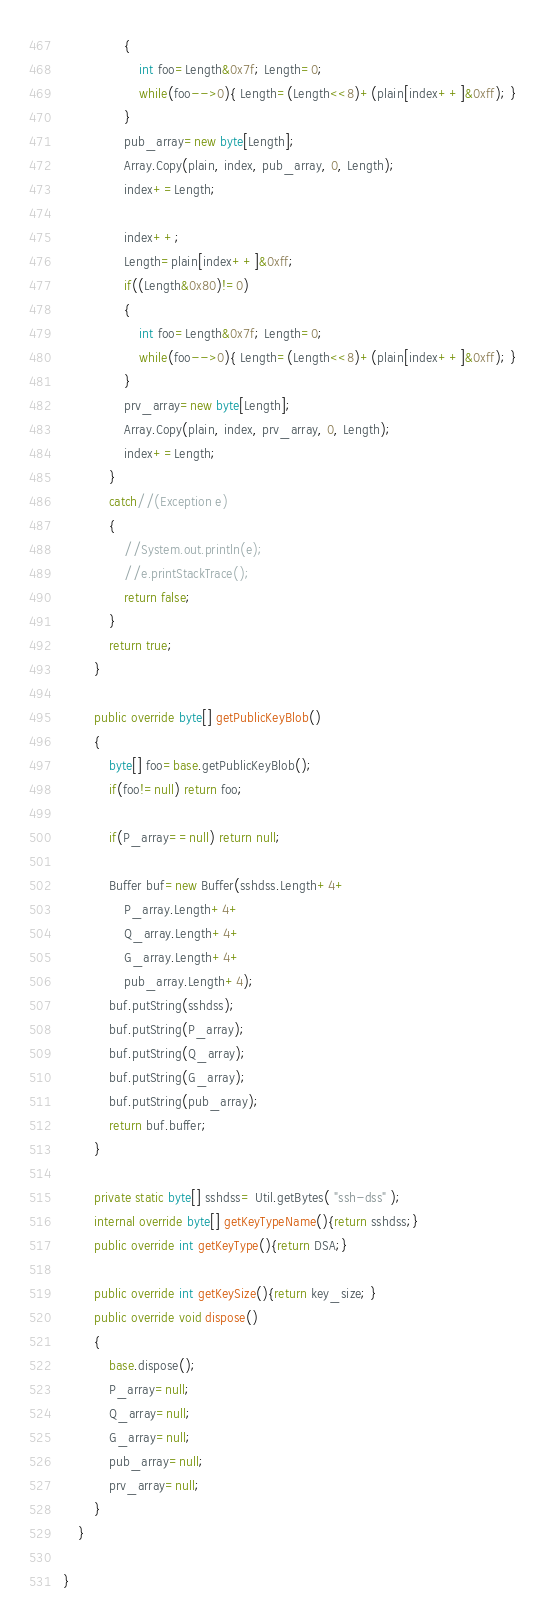Convert code to text. <code><loc_0><loc_0><loc_500><loc_500><_C#_>				{
					int foo=Length&0x7f; Length=0;
					while(foo-->0){ Length=(Length<<8)+(plain[index++]&0xff); }
				}
				pub_array=new byte[Length];
				Array.Copy(plain, index, pub_array, 0, Length);
				index+=Length;

				index++;
				Length=plain[index++]&0xff;
				if((Length&0x80)!=0)
				{
					int foo=Length&0x7f; Length=0;
					while(foo-->0){ Length=(Length<<8)+(plain[index++]&0xff); }
				}
				prv_array=new byte[Length];
				Array.Copy(plain, index, prv_array, 0, Length);
				index+=Length;
			}
			catch//(Exception e)
			{
				//System.out.println(e);
				//e.printStackTrace();
				return false;
			}
			return true;
		}

		public override byte[] getPublicKeyBlob()
		{
			byte[] foo=base.getPublicKeyBlob();
			if(foo!=null) return foo;

			if(P_array==null) return null;

			Buffer buf=new Buffer(sshdss.Length+4+
				P_array.Length+4+ 
				Q_array.Length+4+ 
				G_array.Length+4+ 
				pub_array.Length+4);
			buf.putString(sshdss);
			buf.putString(P_array);
			buf.putString(Q_array);
			buf.putString(G_array);
			buf.putString(pub_array);
			return buf.buffer;
		}

		private static byte[] sshdss= Util.getBytes( "ssh-dss" );
		internal override byte[] getKeyTypeName(){return sshdss;}
		public override int getKeyType(){return DSA;}

		public override int getKeySize(){return key_size; }
		public override void dispose()
		{
			base.dispose();
			P_array=null;
			Q_array=null;
			G_array=null;
			pub_array=null;
			prv_array=null;
		}
	}

}
</code> 